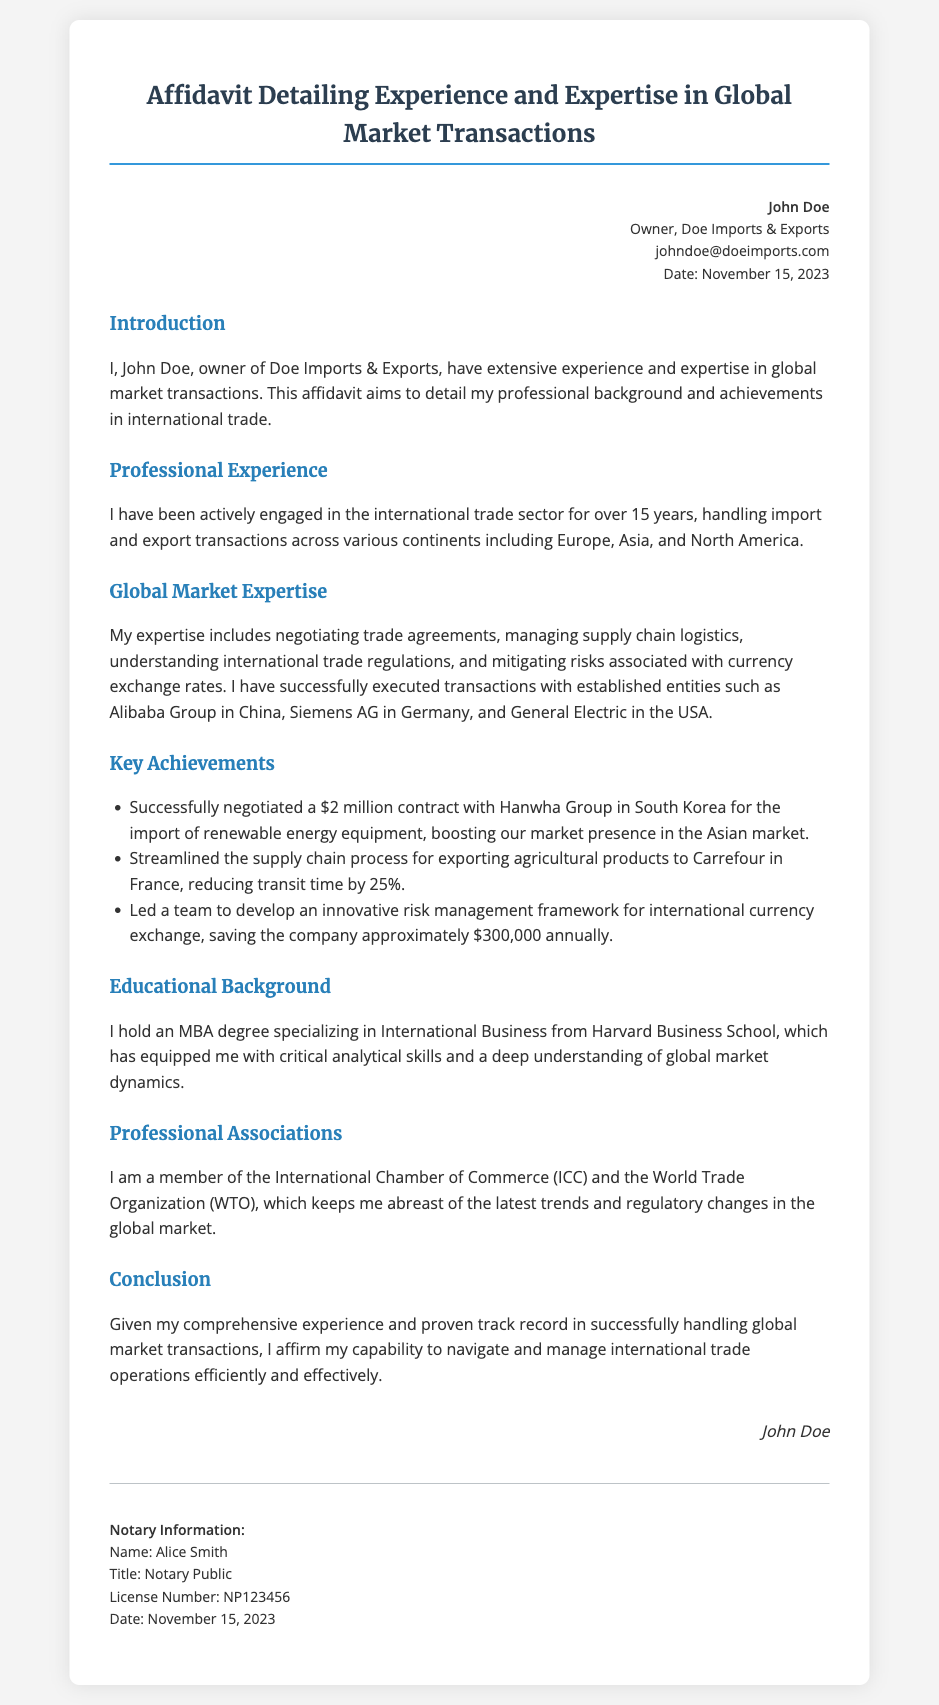What is the name of the affidavit's author? The name of the affidavit's author is mentioned in the header information at the top of the document.
Answer: John Doe How many years of experience does John Doe have in international trade? The document states that John Doe has been actively engaged in the international trade sector for over 15 years.
Answer: 15 years Which company did John Doe negotiate a contract with for renewable energy equipment? The affidavit lists Hanwha Group in South Korea as the company with which John Doe successfully negotiated a contract.
Answer: Hanwha Group What degree does John Doe hold? The educational background section specifies John Doe's degree, which is highlighted to denote its significance.
Answer: MBA What is the estimated annual savings from the risk management framework developed by John Doe's team? The document mentions the approximate savings achieved through the innovative risk management framework.
Answer: $300,000 What role does John Doe have in his company? The header information indicates John Doe's position within the company he owns.
Answer: Owner What organizations is John Doe a member of? The document lists the professional associations to which John Doe belongs, emphasizing his involvement in international trade.
Answer: International Chamber of Commerce and World Trade Organization What is the date of the affidavit's signing? The date of signing is explicitly mentioned in the header and notary sections of the document.
Answer: November 15, 2023 